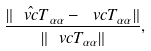Convert formula to latex. <formula><loc_0><loc_0><loc_500><loc_500>\frac { \| \hat { \ v c { T } } _ { \alpha \alpha } - \ v c { T } _ { \alpha \alpha } \| } { \| \ v c { T } _ { \alpha \alpha } \| } ,</formula> 